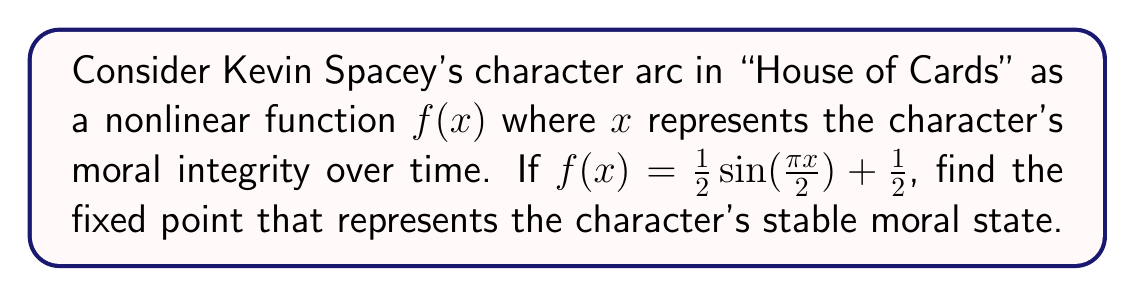Could you help me with this problem? To find the fixed point, we need to solve the equation $f(x) = x$. This means:

1) Set up the equation:
   $$\frac{1}{2}\sin(\frac{\pi x}{2}) + \frac{1}{2} = x$$

2) Rearrange the equation:
   $$\frac{1}{2}\sin(\frac{\pi x}{2}) = x - \frac{1}{2}$$

3) Multiply both sides by 2:
   $$\sin(\frac{\pi x}{2}) = 2x - 1$$

4) This equation cannot be solved algebraically. We need to use a numerical method like the fixed-point iteration.

5) Start with an initial guess, say $x_0 = 0.5$, and iterate:
   $$x_{n+1} = f(x_n) = \frac{1}{2}\sin(\frac{\pi x_n}{2}) + \frac{1}{2}$$

6) After several iterations:
   $x_1 \approx 0.6533$
   $x_2 \approx 0.7071$
   $x_3 \approx 0.7247$
   $x_4 \approx 0.7320$
   $x_5 \approx 0.7349$

7) The sequence converges to approximately 0.7368, which is the fixed point.

This fixed point represents the stable moral state of Spacey's character in the series.
Answer: 0.7368 